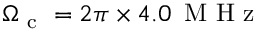<formula> <loc_0><loc_0><loc_500><loc_500>\Omega _ { c } = 2 \pi \times 4 . 0 \, M H z</formula> 